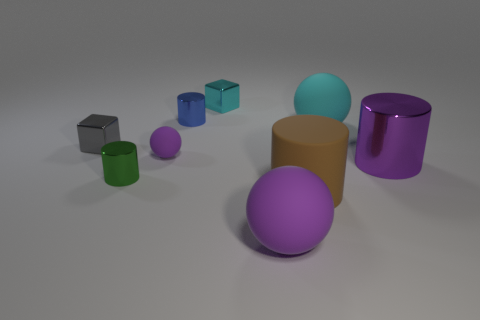Add 1 gray cubes. How many objects exist? 10 Subtract all cylinders. How many objects are left? 5 Subtract 1 purple spheres. How many objects are left? 8 Subtract all blue metallic cylinders. Subtract all big cyan matte spheres. How many objects are left? 7 Add 5 large purple cylinders. How many large purple cylinders are left? 6 Add 4 large brown cylinders. How many large brown cylinders exist? 5 